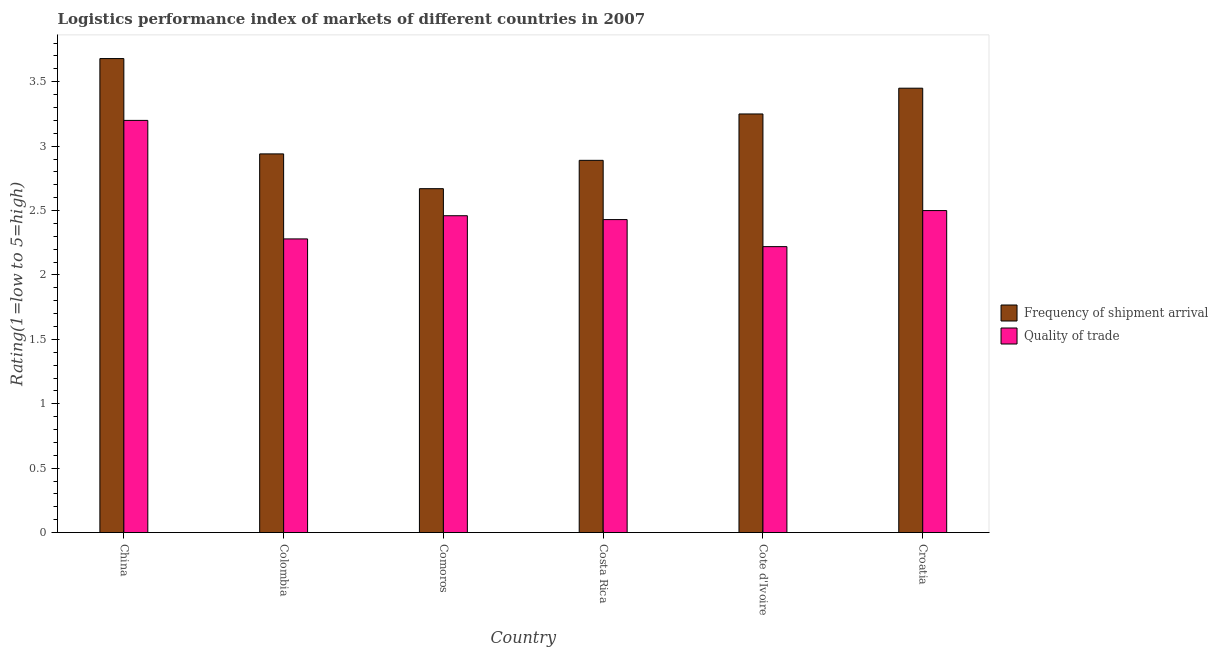Are the number of bars per tick equal to the number of legend labels?
Keep it short and to the point. Yes. Are the number of bars on each tick of the X-axis equal?
Give a very brief answer. Yes. How many bars are there on the 6th tick from the left?
Your answer should be compact. 2. How many bars are there on the 6th tick from the right?
Your response must be concise. 2. What is the label of the 6th group of bars from the left?
Give a very brief answer. Croatia. What is the lpi quality of trade in Costa Rica?
Give a very brief answer. 2.43. Across all countries, what is the minimum lpi quality of trade?
Provide a succinct answer. 2.22. In which country was the lpi quality of trade maximum?
Your answer should be compact. China. In which country was the lpi quality of trade minimum?
Your response must be concise. Cote d'Ivoire. What is the total lpi quality of trade in the graph?
Provide a succinct answer. 15.09. What is the difference between the lpi quality of trade in China and that in Cote d'Ivoire?
Ensure brevity in your answer.  0.98. What is the difference between the lpi of frequency of shipment arrival in Cote d'Ivoire and the lpi quality of trade in Colombia?
Make the answer very short. 0.97. What is the average lpi quality of trade per country?
Offer a terse response. 2.52. What is the difference between the lpi of frequency of shipment arrival and lpi quality of trade in Comoros?
Your answer should be very brief. 0.21. What is the ratio of the lpi quality of trade in Colombia to that in Croatia?
Ensure brevity in your answer.  0.91. Is the difference between the lpi of frequency of shipment arrival in Colombia and Croatia greater than the difference between the lpi quality of trade in Colombia and Croatia?
Give a very brief answer. No. What is the difference between the highest and the second highest lpi quality of trade?
Provide a short and direct response. 0.7. What is the difference between the highest and the lowest lpi quality of trade?
Make the answer very short. 0.98. What does the 1st bar from the left in Costa Rica represents?
Keep it short and to the point. Frequency of shipment arrival. What does the 2nd bar from the right in Comoros represents?
Offer a very short reply. Frequency of shipment arrival. How many countries are there in the graph?
Your response must be concise. 6. Does the graph contain grids?
Ensure brevity in your answer.  No. How many legend labels are there?
Your response must be concise. 2. How are the legend labels stacked?
Your response must be concise. Vertical. What is the title of the graph?
Keep it short and to the point. Logistics performance index of markets of different countries in 2007. What is the label or title of the Y-axis?
Keep it short and to the point. Rating(1=low to 5=high). What is the Rating(1=low to 5=high) in Frequency of shipment arrival in China?
Your answer should be very brief. 3.68. What is the Rating(1=low to 5=high) in Frequency of shipment arrival in Colombia?
Your answer should be very brief. 2.94. What is the Rating(1=low to 5=high) of Quality of trade in Colombia?
Provide a short and direct response. 2.28. What is the Rating(1=low to 5=high) of Frequency of shipment arrival in Comoros?
Make the answer very short. 2.67. What is the Rating(1=low to 5=high) of Quality of trade in Comoros?
Your response must be concise. 2.46. What is the Rating(1=low to 5=high) of Frequency of shipment arrival in Costa Rica?
Provide a short and direct response. 2.89. What is the Rating(1=low to 5=high) in Quality of trade in Costa Rica?
Your response must be concise. 2.43. What is the Rating(1=low to 5=high) of Quality of trade in Cote d'Ivoire?
Your answer should be compact. 2.22. What is the Rating(1=low to 5=high) in Frequency of shipment arrival in Croatia?
Your answer should be very brief. 3.45. Across all countries, what is the maximum Rating(1=low to 5=high) of Frequency of shipment arrival?
Offer a very short reply. 3.68. Across all countries, what is the maximum Rating(1=low to 5=high) in Quality of trade?
Make the answer very short. 3.2. Across all countries, what is the minimum Rating(1=low to 5=high) of Frequency of shipment arrival?
Give a very brief answer. 2.67. Across all countries, what is the minimum Rating(1=low to 5=high) of Quality of trade?
Ensure brevity in your answer.  2.22. What is the total Rating(1=low to 5=high) of Frequency of shipment arrival in the graph?
Offer a terse response. 18.88. What is the total Rating(1=low to 5=high) of Quality of trade in the graph?
Offer a very short reply. 15.09. What is the difference between the Rating(1=low to 5=high) in Frequency of shipment arrival in China and that in Colombia?
Your response must be concise. 0.74. What is the difference between the Rating(1=low to 5=high) of Quality of trade in China and that in Colombia?
Your response must be concise. 0.92. What is the difference between the Rating(1=low to 5=high) of Frequency of shipment arrival in China and that in Comoros?
Provide a succinct answer. 1.01. What is the difference between the Rating(1=low to 5=high) in Quality of trade in China and that in Comoros?
Give a very brief answer. 0.74. What is the difference between the Rating(1=low to 5=high) in Frequency of shipment arrival in China and that in Costa Rica?
Provide a short and direct response. 0.79. What is the difference between the Rating(1=low to 5=high) in Quality of trade in China and that in Costa Rica?
Provide a succinct answer. 0.77. What is the difference between the Rating(1=low to 5=high) of Frequency of shipment arrival in China and that in Cote d'Ivoire?
Provide a succinct answer. 0.43. What is the difference between the Rating(1=low to 5=high) in Frequency of shipment arrival in China and that in Croatia?
Provide a short and direct response. 0.23. What is the difference between the Rating(1=low to 5=high) of Quality of trade in China and that in Croatia?
Give a very brief answer. 0.7. What is the difference between the Rating(1=low to 5=high) of Frequency of shipment arrival in Colombia and that in Comoros?
Give a very brief answer. 0.27. What is the difference between the Rating(1=low to 5=high) of Quality of trade in Colombia and that in Comoros?
Provide a short and direct response. -0.18. What is the difference between the Rating(1=low to 5=high) in Frequency of shipment arrival in Colombia and that in Costa Rica?
Ensure brevity in your answer.  0.05. What is the difference between the Rating(1=low to 5=high) of Quality of trade in Colombia and that in Costa Rica?
Offer a very short reply. -0.15. What is the difference between the Rating(1=low to 5=high) of Frequency of shipment arrival in Colombia and that in Cote d'Ivoire?
Ensure brevity in your answer.  -0.31. What is the difference between the Rating(1=low to 5=high) of Quality of trade in Colombia and that in Cote d'Ivoire?
Your response must be concise. 0.06. What is the difference between the Rating(1=low to 5=high) in Frequency of shipment arrival in Colombia and that in Croatia?
Keep it short and to the point. -0.51. What is the difference between the Rating(1=low to 5=high) in Quality of trade in Colombia and that in Croatia?
Offer a very short reply. -0.22. What is the difference between the Rating(1=low to 5=high) of Frequency of shipment arrival in Comoros and that in Costa Rica?
Offer a terse response. -0.22. What is the difference between the Rating(1=low to 5=high) of Frequency of shipment arrival in Comoros and that in Cote d'Ivoire?
Offer a terse response. -0.58. What is the difference between the Rating(1=low to 5=high) in Quality of trade in Comoros and that in Cote d'Ivoire?
Offer a terse response. 0.24. What is the difference between the Rating(1=low to 5=high) of Frequency of shipment arrival in Comoros and that in Croatia?
Offer a very short reply. -0.78. What is the difference between the Rating(1=low to 5=high) in Quality of trade in Comoros and that in Croatia?
Keep it short and to the point. -0.04. What is the difference between the Rating(1=low to 5=high) of Frequency of shipment arrival in Costa Rica and that in Cote d'Ivoire?
Offer a terse response. -0.36. What is the difference between the Rating(1=low to 5=high) of Quality of trade in Costa Rica and that in Cote d'Ivoire?
Offer a terse response. 0.21. What is the difference between the Rating(1=low to 5=high) in Frequency of shipment arrival in Costa Rica and that in Croatia?
Your answer should be very brief. -0.56. What is the difference between the Rating(1=low to 5=high) in Quality of trade in Costa Rica and that in Croatia?
Provide a succinct answer. -0.07. What is the difference between the Rating(1=low to 5=high) in Quality of trade in Cote d'Ivoire and that in Croatia?
Your answer should be very brief. -0.28. What is the difference between the Rating(1=low to 5=high) in Frequency of shipment arrival in China and the Rating(1=low to 5=high) in Quality of trade in Comoros?
Give a very brief answer. 1.22. What is the difference between the Rating(1=low to 5=high) in Frequency of shipment arrival in China and the Rating(1=low to 5=high) in Quality of trade in Costa Rica?
Offer a terse response. 1.25. What is the difference between the Rating(1=low to 5=high) in Frequency of shipment arrival in China and the Rating(1=low to 5=high) in Quality of trade in Cote d'Ivoire?
Your answer should be compact. 1.46. What is the difference between the Rating(1=low to 5=high) of Frequency of shipment arrival in China and the Rating(1=low to 5=high) of Quality of trade in Croatia?
Give a very brief answer. 1.18. What is the difference between the Rating(1=low to 5=high) of Frequency of shipment arrival in Colombia and the Rating(1=low to 5=high) of Quality of trade in Comoros?
Your answer should be compact. 0.48. What is the difference between the Rating(1=low to 5=high) in Frequency of shipment arrival in Colombia and the Rating(1=low to 5=high) in Quality of trade in Costa Rica?
Provide a succinct answer. 0.51. What is the difference between the Rating(1=low to 5=high) in Frequency of shipment arrival in Colombia and the Rating(1=low to 5=high) in Quality of trade in Cote d'Ivoire?
Your response must be concise. 0.72. What is the difference between the Rating(1=low to 5=high) in Frequency of shipment arrival in Colombia and the Rating(1=low to 5=high) in Quality of trade in Croatia?
Provide a short and direct response. 0.44. What is the difference between the Rating(1=low to 5=high) in Frequency of shipment arrival in Comoros and the Rating(1=low to 5=high) in Quality of trade in Costa Rica?
Give a very brief answer. 0.24. What is the difference between the Rating(1=low to 5=high) in Frequency of shipment arrival in Comoros and the Rating(1=low to 5=high) in Quality of trade in Cote d'Ivoire?
Keep it short and to the point. 0.45. What is the difference between the Rating(1=low to 5=high) in Frequency of shipment arrival in Comoros and the Rating(1=low to 5=high) in Quality of trade in Croatia?
Keep it short and to the point. 0.17. What is the difference between the Rating(1=low to 5=high) of Frequency of shipment arrival in Costa Rica and the Rating(1=low to 5=high) of Quality of trade in Cote d'Ivoire?
Provide a short and direct response. 0.67. What is the difference between the Rating(1=low to 5=high) in Frequency of shipment arrival in Costa Rica and the Rating(1=low to 5=high) in Quality of trade in Croatia?
Your answer should be compact. 0.39. What is the difference between the Rating(1=low to 5=high) of Frequency of shipment arrival in Cote d'Ivoire and the Rating(1=low to 5=high) of Quality of trade in Croatia?
Your response must be concise. 0.75. What is the average Rating(1=low to 5=high) of Frequency of shipment arrival per country?
Your answer should be very brief. 3.15. What is the average Rating(1=low to 5=high) in Quality of trade per country?
Give a very brief answer. 2.52. What is the difference between the Rating(1=low to 5=high) in Frequency of shipment arrival and Rating(1=low to 5=high) in Quality of trade in China?
Your answer should be very brief. 0.48. What is the difference between the Rating(1=low to 5=high) in Frequency of shipment arrival and Rating(1=low to 5=high) in Quality of trade in Colombia?
Give a very brief answer. 0.66. What is the difference between the Rating(1=low to 5=high) of Frequency of shipment arrival and Rating(1=low to 5=high) of Quality of trade in Comoros?
Your response must be concise. 0.21. What is the difference between the Rating(1=low to 5=high) in Frequency of shipment arrival and Rating(1=low to 5=high) in Quality of trade in Costa Rica?
Provide a succinct answer. 0.46. What is the ratio of the Rating(1=low to 5=high) of Frequency of shipment arrival in China to that in Colombia?
Provide a short and direct response. 1.25. What is the ratio of the Rating(1=low to 5=high) of Quality of trade in China to that in Colombia?
Give a very brief answer. 1.4. What is the ratio of the Rating(1=low to 5=high) of Frequency of shipment arrival in China to that in Comoros?
Your answer should be very brief. 1.38. What is the ratio of the Rating(1=low to 5=high) of Quality of trade in China to that in Comoros?
Your answer should be very brief. 1.3. What is the ratio of the Rating(1=low to 5=high) of Frequency of shipment arrival in China to that in Costa Rica?
Ensure brevity in your answer.  1.27. What is the ratio of the Rating(1=low to 5=high) in Quality of trade in China to that in Costa Rica?
Keep it short and to the point. 1.32. What is the ratio of the Rating(1=low to 5=high) of Frequency of shipment arrival in China to that in Cote d'Ivoire?
Ensure brevity in your answer.  1.13. What is the ratio of the Rating(1=low to 5=high) in Quality of trade in China to that in Cote d'Ivoire?
Offer a very short reply. 1.44. What is the ratio of the Rating(1=low to 5=high) of Frequency of shipment arrival in China to that in Croatia?
Provide a succinct answer. 1.07. What is the ratio of the Rating(1=low to 5=high) in Quality of trade in China to that in Croatia?
Your answer should be very brief. 1.28. What is the ratio of the Rating(1=low to 5=high) of Frequency of shipment arrival in Colombia to that in Comoros?
Provide a short and direct response. 1.1. What is the ratio of the Rating(1=low to 5=high) in Quality of trade in Colombia to that in Comoros?
Ensure brevity in your answer.  0.93. What is the ratio of the Rating(1=low to 5=high) in Frequency of shipment arrival in Colombia to that in Costa Rica?
Keep it short and to the point. 1.02. What is the ratio of the Rating(1=low to 5=high) of Quality of trade in Colombia to that in Costa Rica?
Provide a succinct answer. 0.94. What is the ratio of the Rating(1=low to 5=high) in Frequency of shipment arrival in Colombia to that in Cote d'Ivoire?
Offer a terse response. 0.9. What is the ratio of the Rating(1=low to 5=high) in Frequency of shipment arrival in Colombia to that in Croatia?
Offer a terse response. 0.85. What is the ratio of the Rating(1=low to 5=high) of Quality of trade in Colombia to that in Croatia?
Offer a terse response. 0.91. What is the ratio of the Rating(1=low to 5=high) of Frequency of shipment arrival in Comoros to that in Costa Rica?
Make the answer very short. 0.92. What is the ratio of the Rating(1=low to 5=high) in Quality of trade in Comoros to that in Costa Rica?
Provide a short and direct response. 1.01. What is the ratio of the Rating(1=low to 5=high) of Frequency of shipment arrival in Comoros to that in Cote d'Ivoire?
Ensure brevity in your answer.  0.82. What is the ratio of the Rating(1=low to 5=high) in Quality of trade in Comoros to that in Cote d'Ivoire?
Your answer should be very brief. 1.11. What is the ratio of the Rating(1=low to 5=high) in Frequency of shipment arrival in Comoros to that in Croatia?
Your response must be concise. 0.77. What is the ratio of the Rating(1=low to 5=high) in Quality of trade in Comoros to that in Croatia?
Your answer should be very brief. 0.98. What is the ratio of the Rating(1=low to 5=high) in Frequency of shipment arrival in Costa Rica to that in Cote d'Ivoire?
Give a very brief answer. 0.89. What is the ratio of the Rating(1=low to 5=high) of Quality of trade in Costa Rica to that in Cote d'Ivoire?
Offer a very short reply. 1.09. What is the ratio of the Rating(1=low to 5=high) in Frequency of shipment arrival in Costa Rica to that in Croatia?
Your answer should be compact. 0.84. What is the ratio of the Rating(1=low to 5=high) of Quality of trade in Costa Rica to that in Croatia?
Your answer should be very brief. 0.97. What is the ratio of the Rating(1=low to 5=high) in Frequency of shipment arrival in Cote d'Ivoire to that in Croatia?
Your answer should be very brief. 0.94. What is the ratio of the Rating(1=low to 5=high) in Quality of trade in Cote d'Ivoire to that in Croatia?
Give a very brief answer. 0.89. What is the difference between the highest and the second highest Rating(1=low to 5=high) of Frequency of shipment arrival?
Your answer should be compact. 0.23. What is the difference between the highest and the lowest Rating(1=low to 5=high) of Frequency of shipment arrival?
Keep it short and to the point. 1.01. What is the difference between the highest and the lowest Rating(1=low to 5=high) in Quality of trade?
Ensure brevity in your answer.  0.98. 